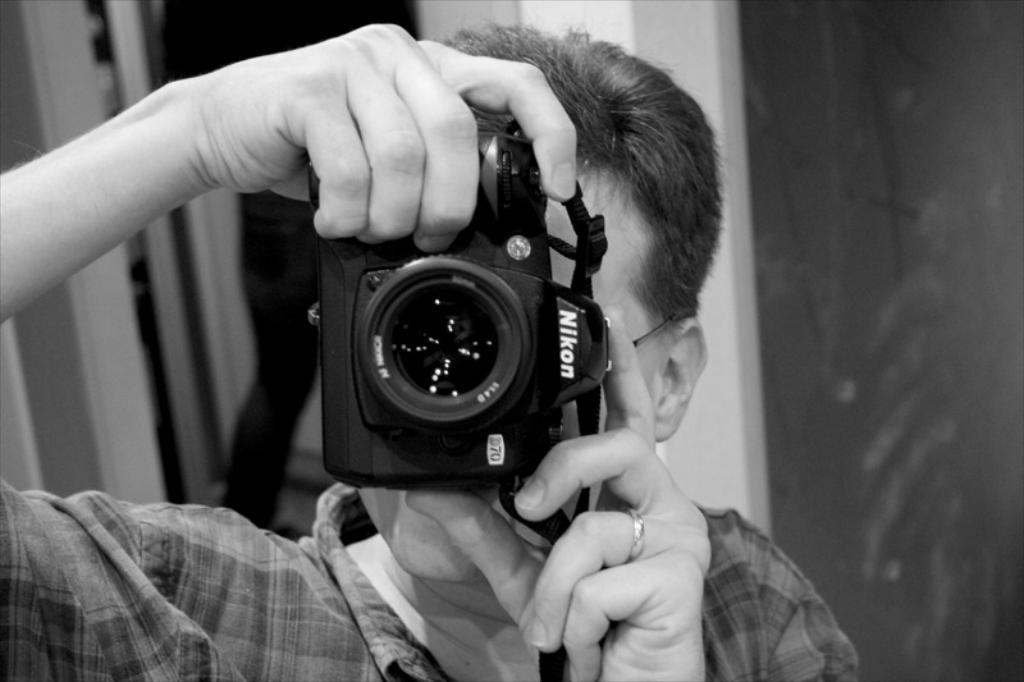What is the main subject of the image? The main subject of the image is a man. What is the man holding in his hands? The man is holding a camera in his hands. What is the man doing with the camera? The man is clicking pictures with the camera. What type of appliance is the man using to fly in the image? There is no appliance or flying depicted in the image; the man is simply holding a camera and clicking pictures. 